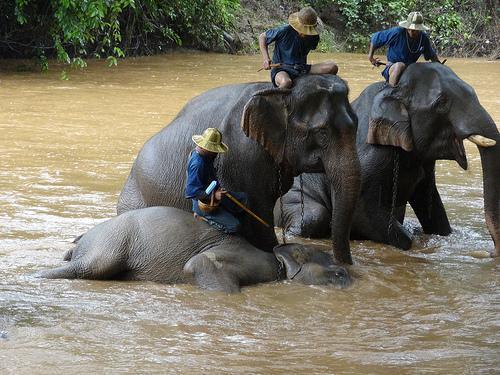How many people are in the photo?
Give a very brief answer. 3. How many elephants are standing up in the water?
Give a very brief answer. 2. 